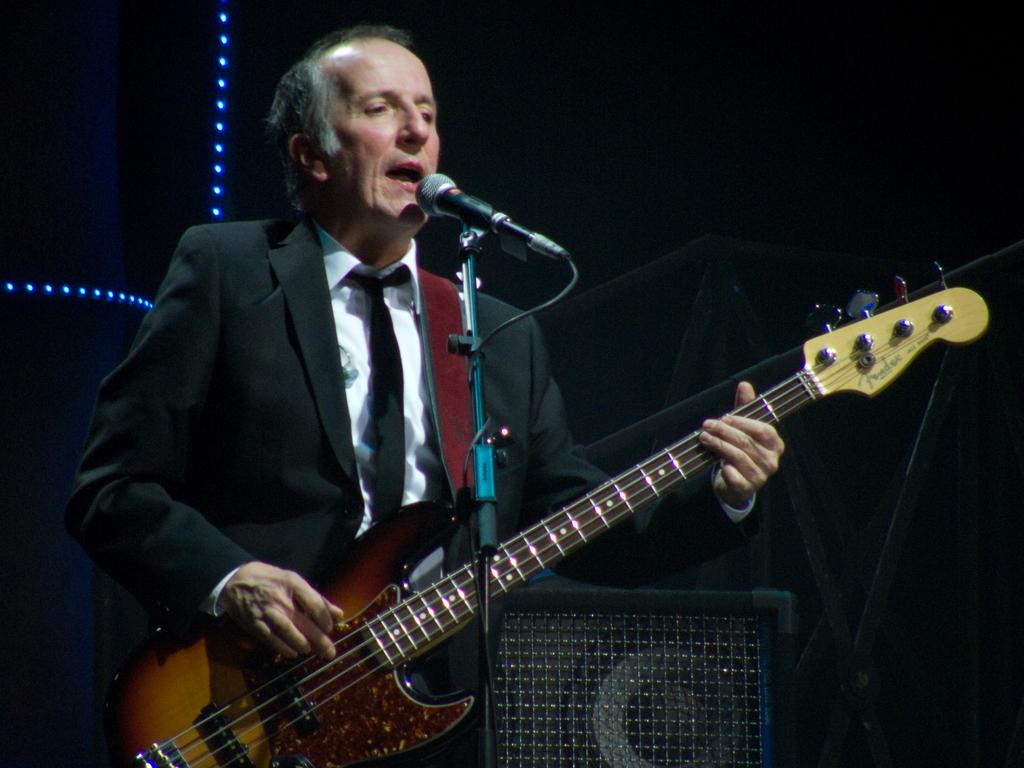What is the person in the image doing? The person is playing a guitar. What is the person wearing? The person is wearing a black suit. What object is in front of the person? There is a microphone in front of the person. What color is the sheet in the background of the image? The sheet in the background of the image is black. How many cherries are on the guitar in the image? There are no cherries present on the guitar in the image. What type of star can be seen in the background of the image? There is no star visible in the background of the image; it features a black color sheet. 